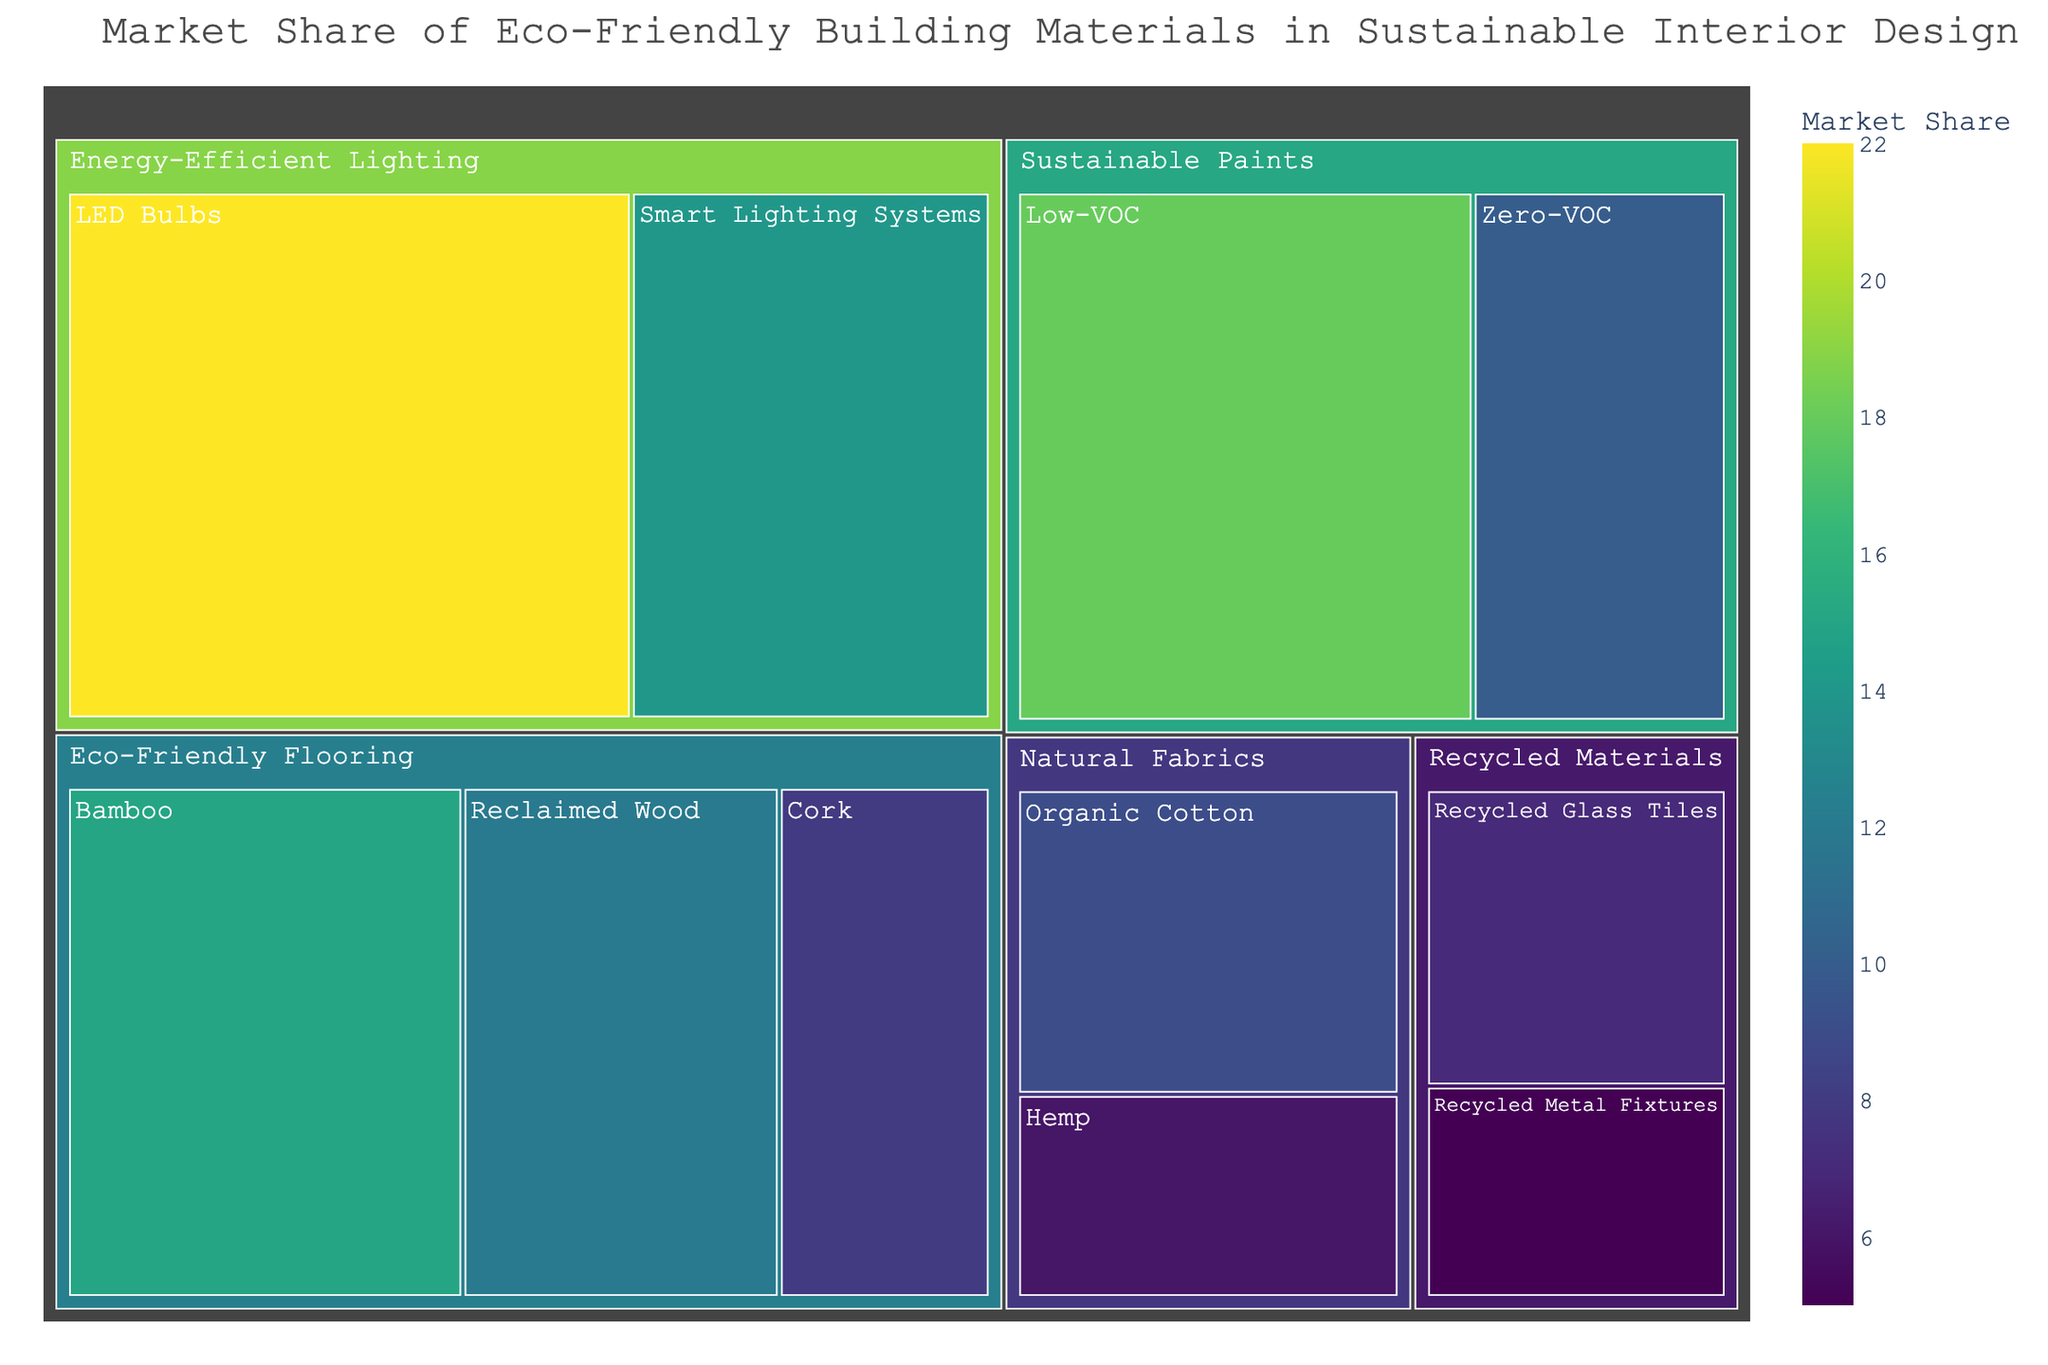What's the largest subcategory in the Treemap? The Treemap represents the market share of various eco-friendly building materials. The subcategory with the highest market share is indicated by the largest block. From a visual inspection, the 'LED Bulbs' in the 'Energy-Efficient Lighting' category appears to be the largest.
Answer: LED Bulbs Which category has the highest total market share? To determine the category with the highest total market share, we sum up the market shares of all subcategories within each category. 'Energy-Efficient Lighting' has 'LED Bulbs' (22%) and 'Smart Lighting Systems' (14%), totaling 36%, which is the highest.
Answer: Energy-Efficient Lighting What is the combined market share of Recycled Materials? Combine the market shares of 'Recycled Glass Tiles' (7%) and 'Recycled Metal Fixtures' (5%) within the 'Recycled Materials' category. So, the total market share is 7% + 5% = 12%.
Answer: 12% Which has a higher market share: Organic Cotton or Hemp? By looking at the subcategories under 'Natural Fabrics', the market share of 'Organic Cotton' is 9%, and 'Hemp' is 6%. 'Organic Cotton' has the higher market share.
Answer: Organic Cotton How does the market share of Low-VOC paints compare to Zero-VOC paints? The subcategory 'Low-VOC' in 'Sustainable Paints' has an 18% market share, while 'Zero-VOC' has 10%. 'Low-VOC' has a greater market share than 'Zero-VOC'.
Answer: Low-VOC paints What is the total market share for all types of eco-friendly flooring combined? Add the market shares of 'Bamboo' (15%), 'Cork' (8%), and 'Reclaimed Wood' (12%) under 'Eco-Friendly Flooring'. So, 15% + 8% + 12% = 35%.
Answer: 35% Which category has the smallest individual market share value, and what is it? Look across all the subcategories to find the smallest individual market share. 'Recycled Metal Fixtures' under 'Recycled Materials' has the smallest share of 5%.
Answer: Recycled Materials with Recycled Metal Fixtures How does the market share of Bamboo flooring compare to Cork flooring? Within the 'Eco-Friendly Flooring' category, 'Bamboo' flooring has a market share of 15%, whereas 'Cork' flooring has 8%. Therefore, 'Bamboo' flooring has a larger market share.
Answer: Bamboo What is the difference in market share between Smart Lighting Systems and Low-VOC Paints? The market share of 'Smart Lighting Systems' is 14% and that of 'Low-VOC Paints' is 18%. The difference in their market shares is 18% - 14% = 4%.
Answer: 4% 